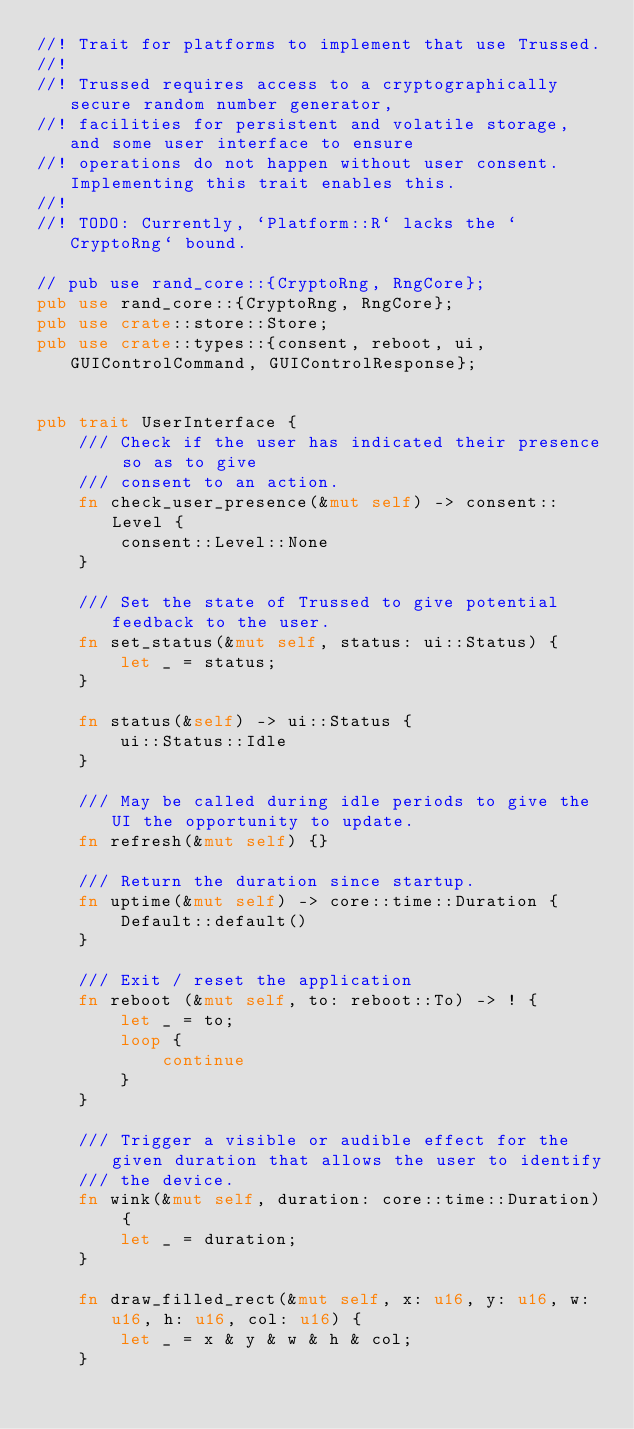Convert code to text. <code><loc_0><loc_0><loc_500><loc_500><_Rust_>//! Trait for platforms to implement that use Trussed.
//!
//! Trussed requires access to a cryptographically secure random number generator,
//! facilities for persistent and volatile storage, and some user interface to ensure
//! operations do not happen without user consent. Implementing this trait enables this.
//!
//! TODO: Currently, `Platform::R` lacks the `CryptoRng` bound.

// pub use rand_core::{CryptoRng, RngCore};
pub use rand_core::{CryptoRng, RngCore};
pub use crate::store::Store;
pub use crate::types::{consent, reboot, ui, GUIControlCommand, GUIControlResponse};


pub trait UserInterface {
    /// Check if the user has indicated their presence so as to give
    /// consent to an action.
    fn check_user_presence(&mut self) -> consent::Level {
        consent::Level::None
    }

    /// Set the state of Trussed to give potential feedback to the user.
    fn set_status(&mut self, status: ui::Status) {
        let _ = status;
    }

    fn status(&self) -> ui::Status {
        ui::Status::Idle
    }

    /// May be called during idle periods to give the UI the opportunity to update.
    fn refresh(&mut self) {}

    /// Return the duration since startup.
    fn uptime(&mut self) -> core::time::Duration {
        Default::default()
    }

    /// Exit / reset the application
    fn reboot (&mut self, to: reboot::To) -> ! {
        let _ = to;
        loop {
            continue
        }
    }

    /// Trigger a visible or audible effect for the given duration that allows the user to identify
    /// the device.
    fn wink(&mut self, duration: core::time::Duration) {
        let _ = duration;
    }

    fn draw_filled_rect(&mut self, x: u16, y: u16, w: u16, h: u16, col: u16) {
        let _ = x & y & w & h & col;
    }</code> 